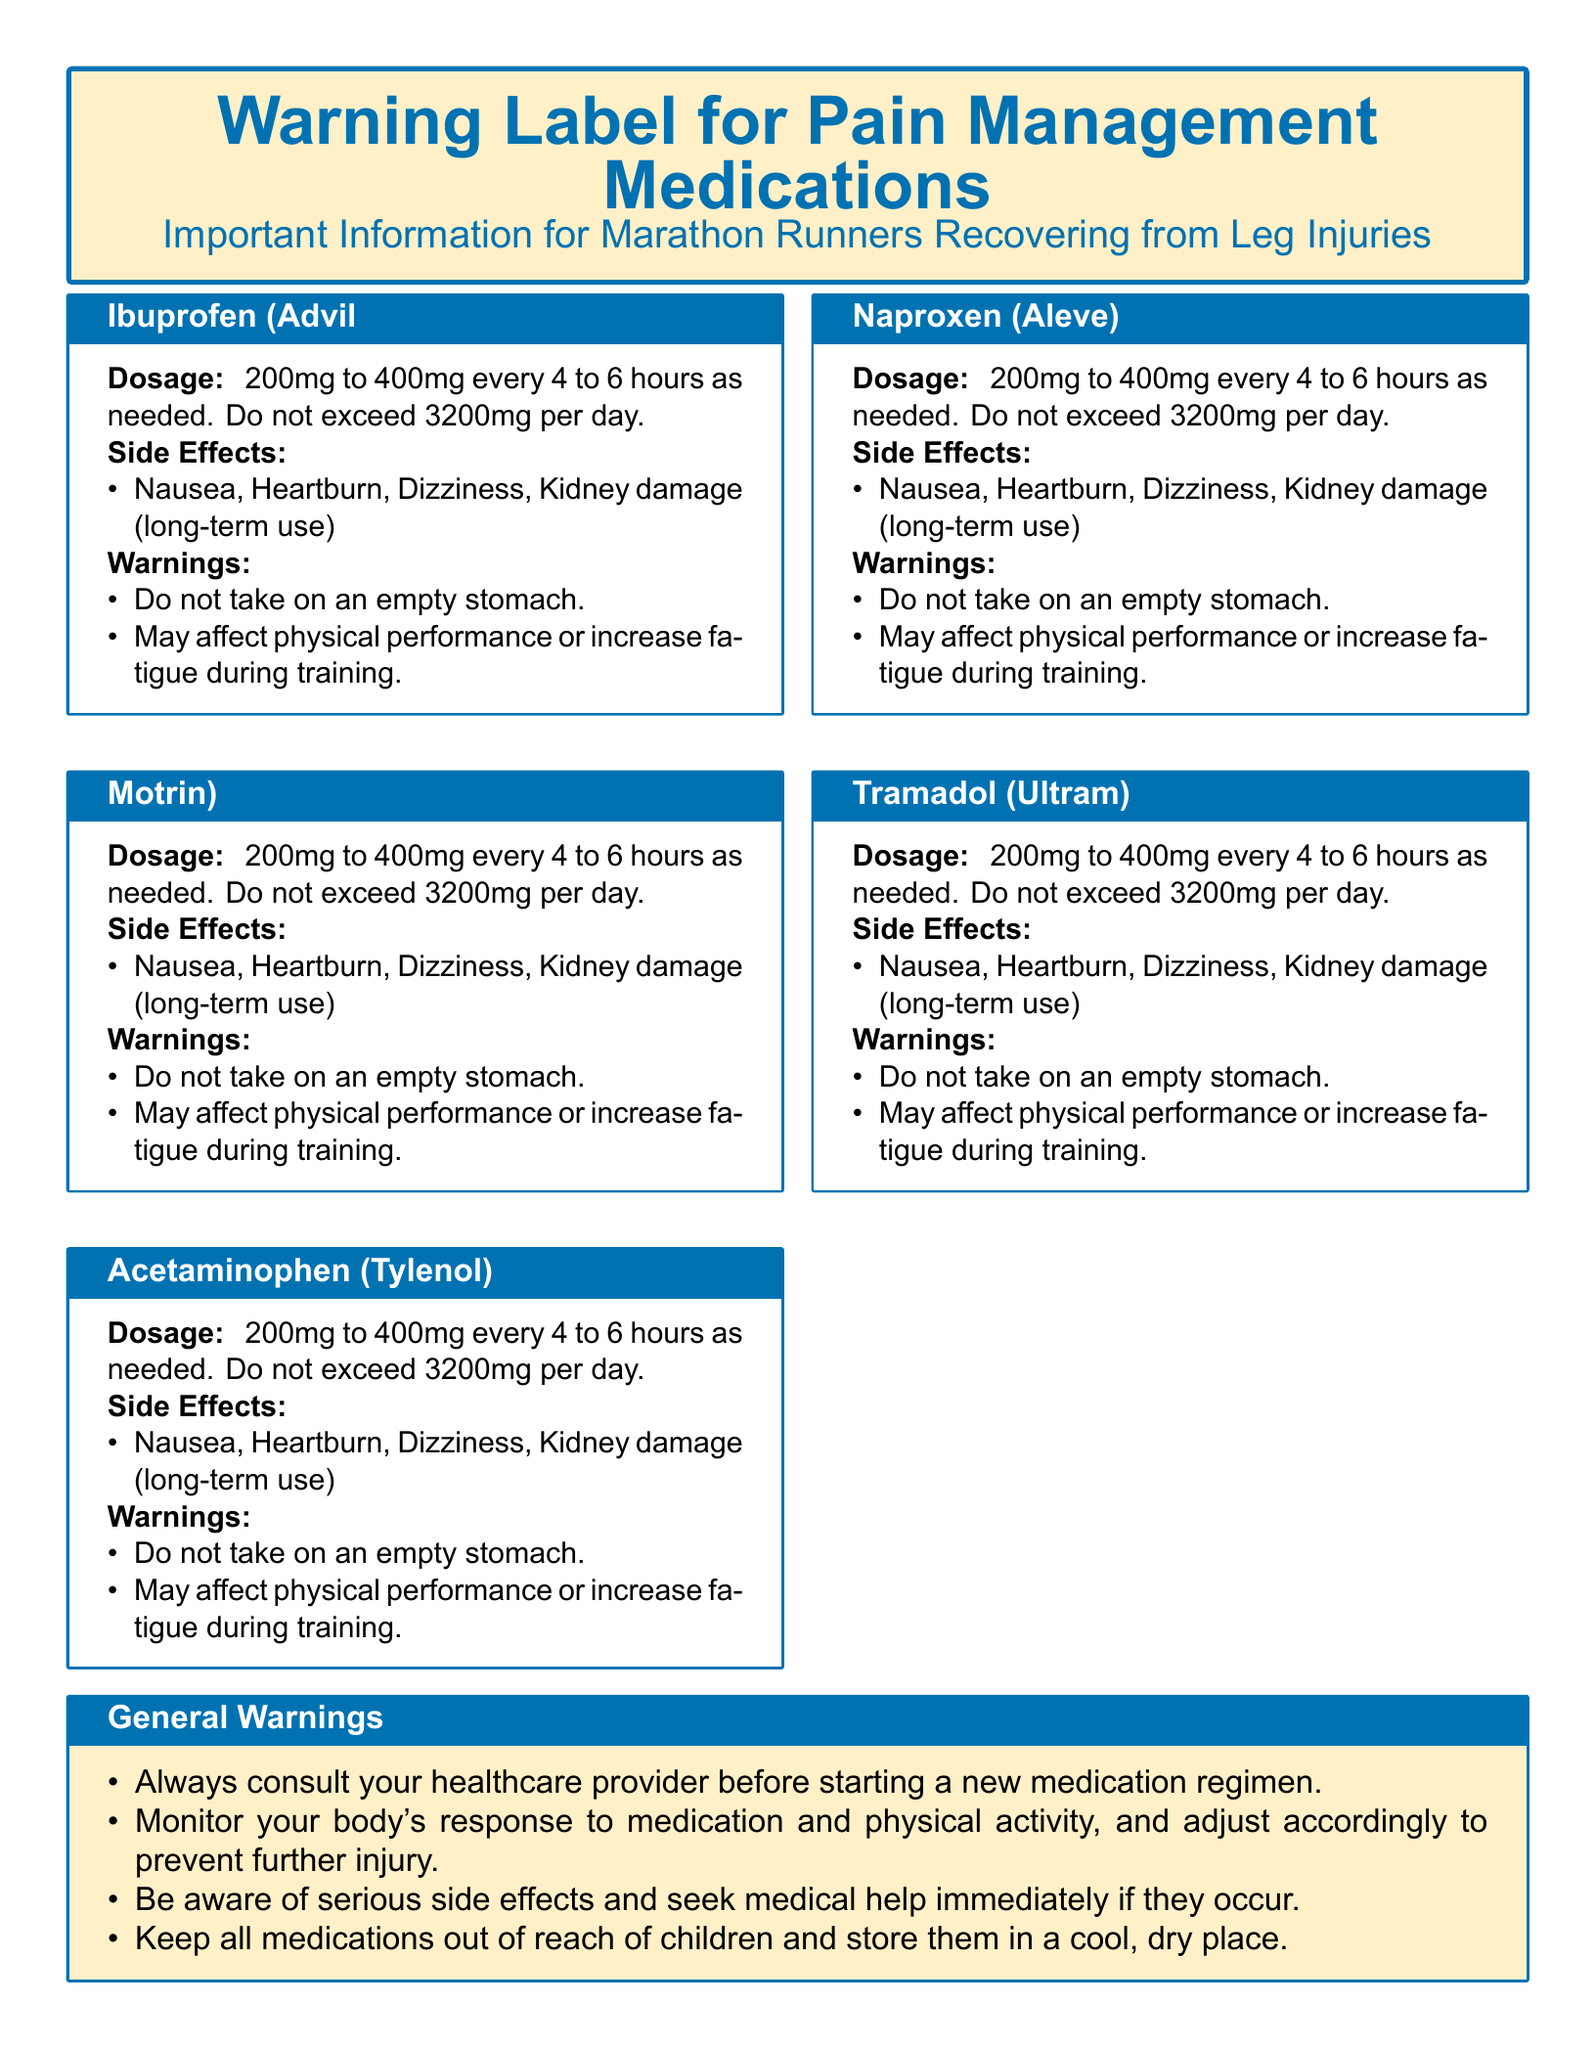What is the dosage range for Ibuprofen? The dosage range for Ibuprofen is 200mg to 400mg every 4 to 6 hours as needed.
Answer: 200mg to 400mg What is a common side effect of Acetaminophen? A common side effect of Acetaminophen is liver damage (excessive use).
Answer: Liver damage (excessive use) What should be avoided while taking Naproxen? Alcohol consumption should be avoided while taking Naproxen.
Answer: Alcohol consumption What is the maximum daily dosage for Tramadol? The maximum daily dosage for Tramadol is 400mg.
Answer: 400mg What do the warnings suggest about physical activity? The warnings suggest that the medication may affect physical performance or increase fatigue during training.
Answer: May affect physical performance What do you need to do before starting a new medication regimen? You need to consult your healthcare provider before starting a new medication regimen.
Answer: Consult your healthcare provider What storage advice is given in the document? The document advises to keep all medications out of reach of children and store them in a cool, dry place.
Answer: Out of reach of children What is the side effect of risk associated with Tramadol? The side effect of Tramadol includes risk of dependency.
Answer: Risk of dependency What do you monitor while using medication and training? You should monitor your body's response to medication and physical activity.
Answer: Body's response 